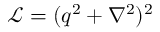Convert formula to latex. <formula><loc_0><loc_0><loc_500><loc_500>\mathcal { L } = ( q ^ { 2 } + \nabla ^ { 2 } ) ^ { 2 }</formula> 